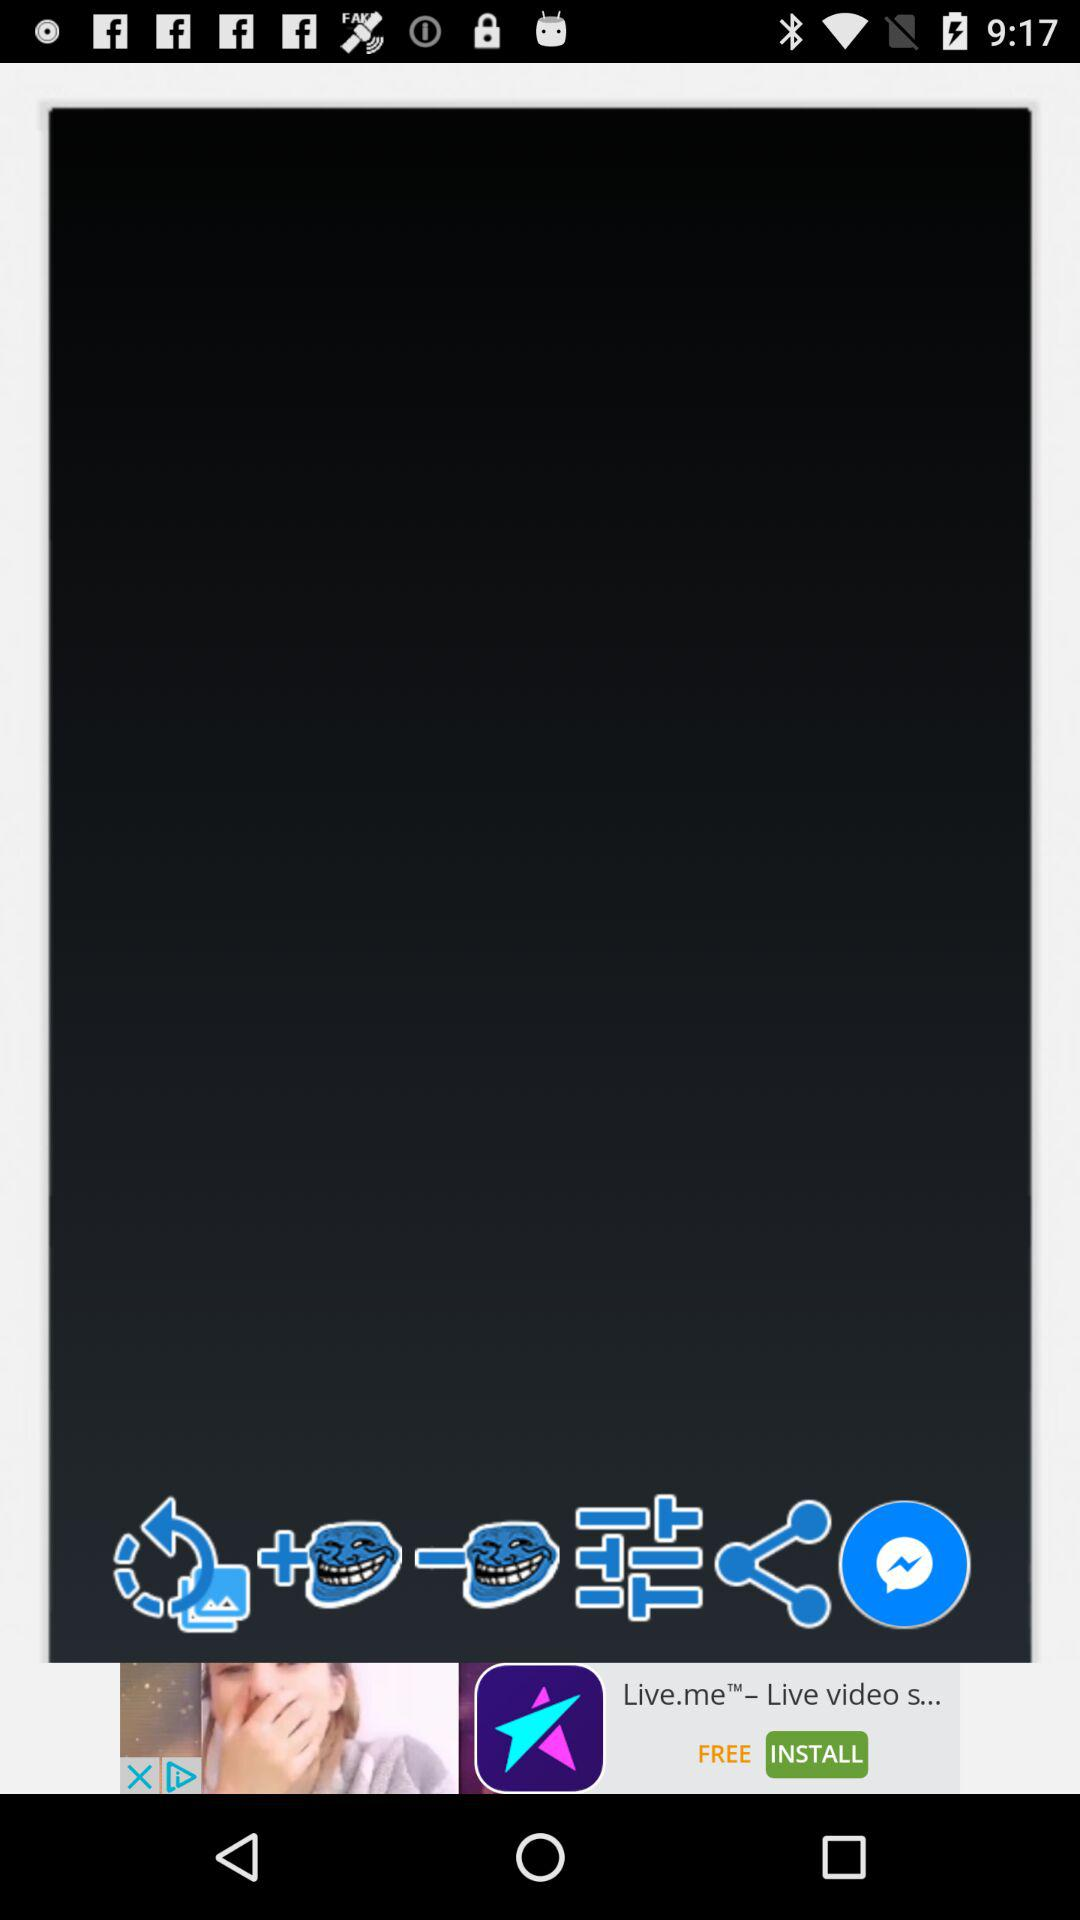How many troll face stickers are on the screen?
Answer the question using a single word or phrase. 2 